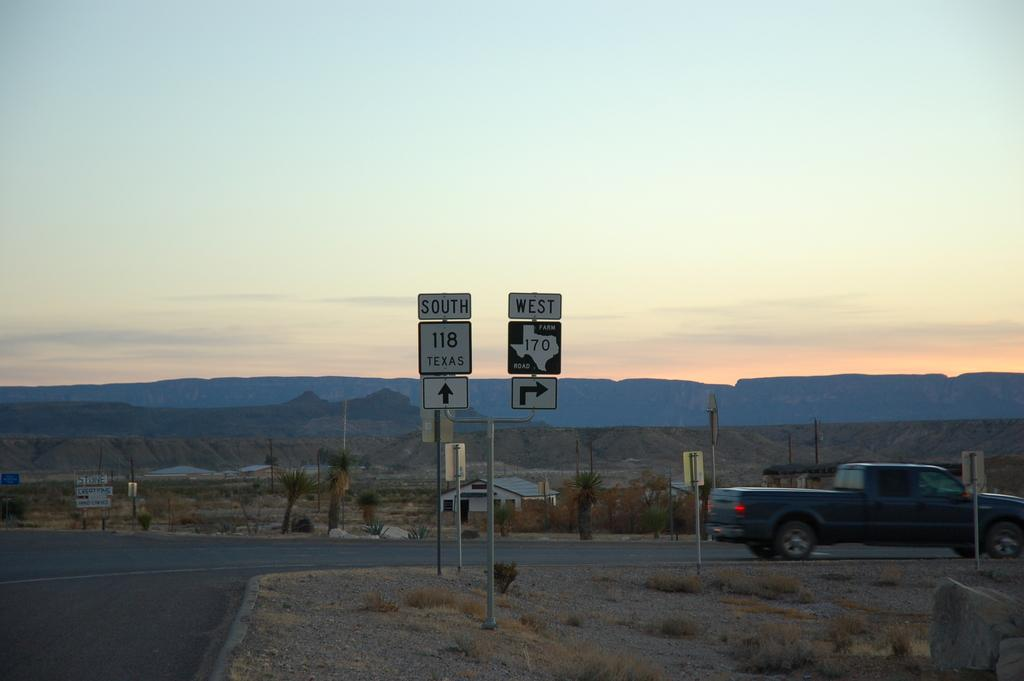What structures can be seen in the image? There are poles and boards visible in the image. What type of natural environment is present in the image? There is grass, plants, and trees in the image. What is the man-made structure on the road in the image? There is a vehicle on the road in the image. What can be seen in the background of the image? There is a mountain and the sky visible in the background of the image. What type of linen is being used to cover the airport runway in the image? There is no airport or runway present in the image, and therefore no linen can be observed. 